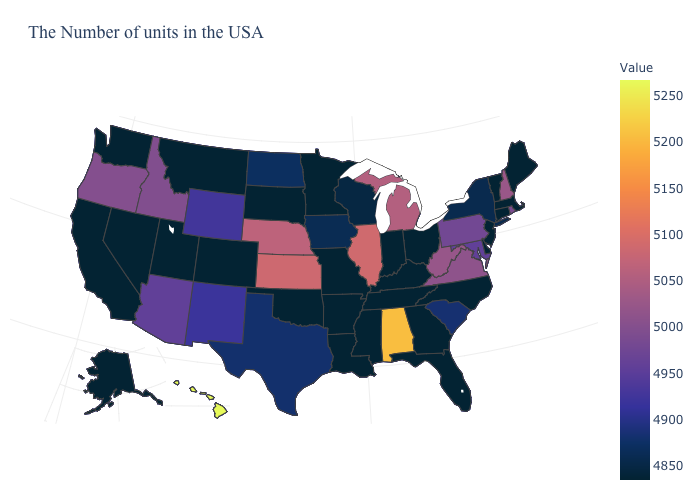Which states have the lowest value in the MidWest?
Give a very brief answer. Ohio, Indiana, Missouri, Minnesota, South Dakota. Which states have the highest value in the USA?
Keep it brief. Hawaii. Does the map have missing data?
Keep it brief. No. Does the map have missing data?
Answer briefly. No. Does the map have missing data?
Write a very short answer. No. Does Connecticut have a higher value than Virginia?
Give a very brief answer. No. 